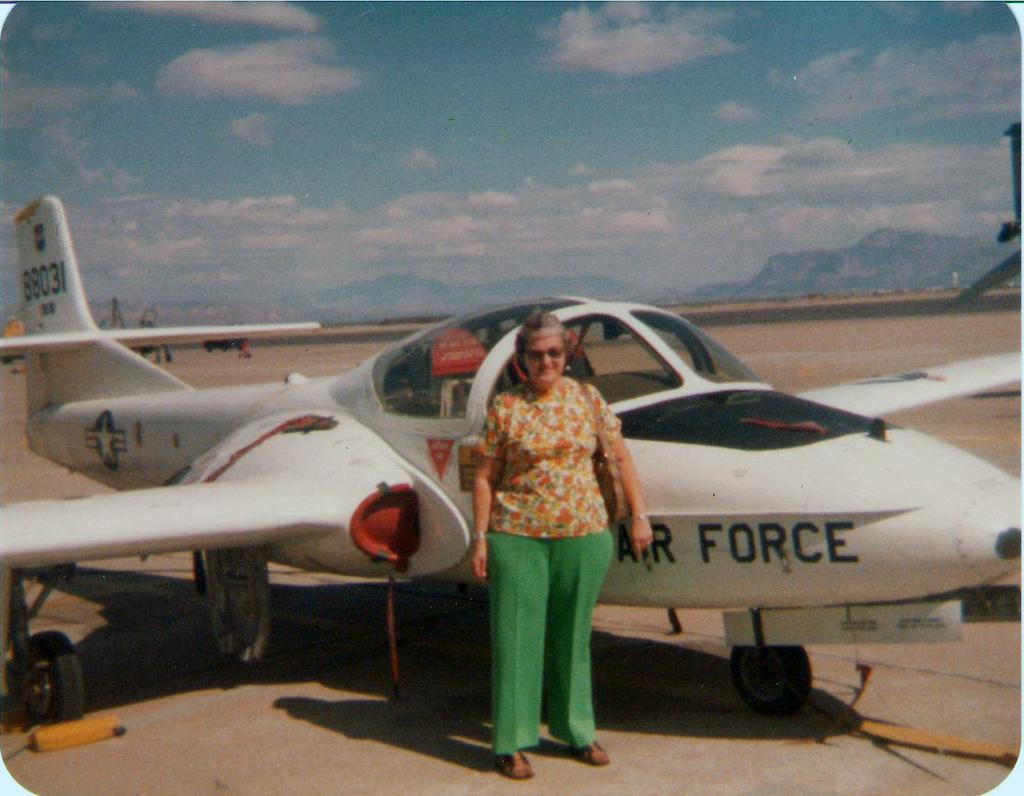<image>
Write a terse but informative summary of the picture. John's grandmother takes a photo near the Air Force airplane. 